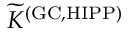Convert formula to latex. <formula><loc_0><loc_0><loc_500><loc_500>{ \widetilde { K } } ^ { ( G C , H I P P ) }</formula> 